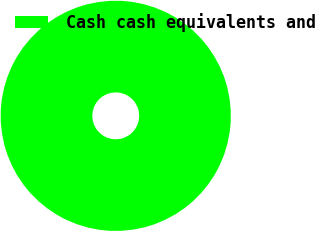Convert chart to OTSL. <chart><loc_0><loc_0><loc_500><loc_500><pie_chart><fcel>Cash cash equivalents and<nl><fcel>100.0%<nl></chart> 